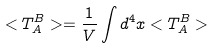Convert formula to latex. <formula><loc_0><loc_0><loc_500><loc_500>< T _ { A } ^ { B } > = \frac { 1 } { V } \int d ^ { 4 } x < T _ { A } ^ { B } ></formula> 